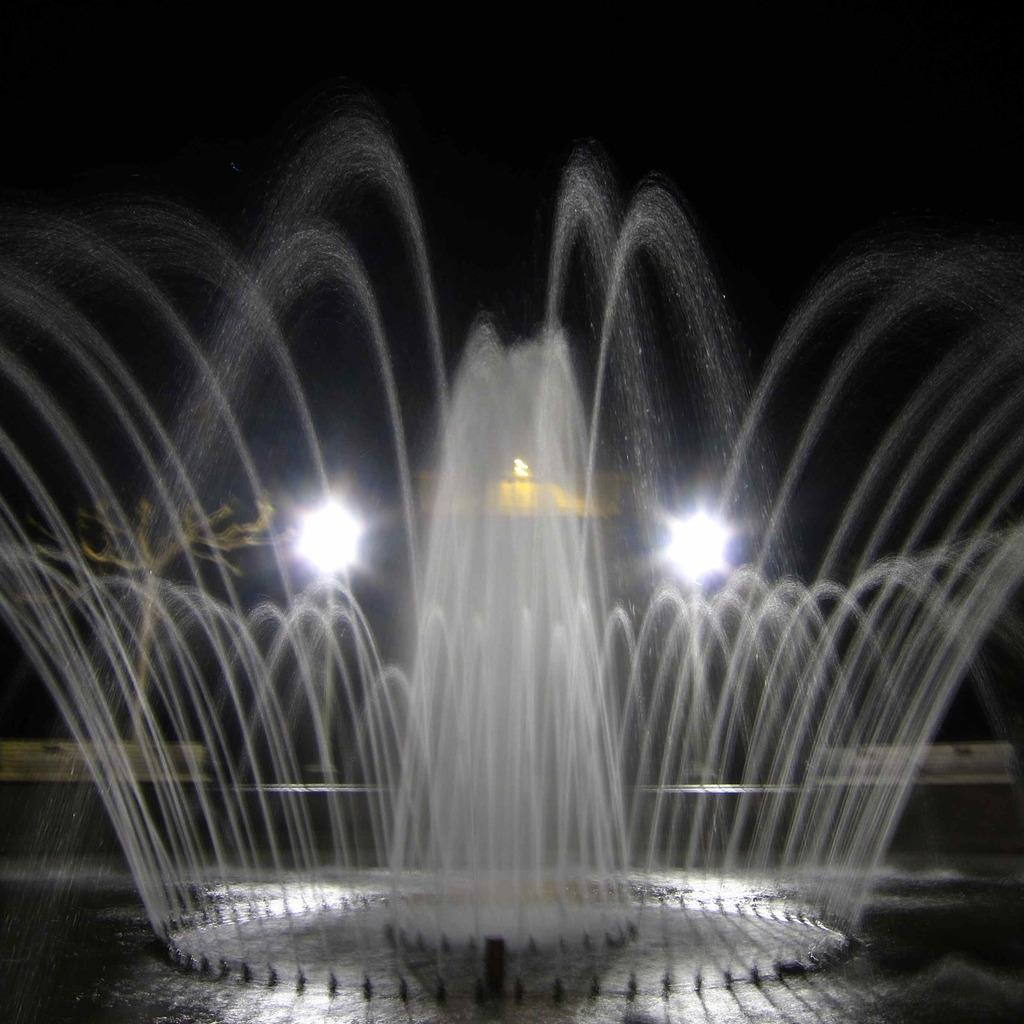What is the main feature in the image? There is a fountain in the image. Can you describe the lighting in the image? There are two lights visible in the background of the image. What shape is the wheel in the image? There is no wheel present in the image. What is the reason for the fountain in the image? The reason for the fountain in the image cannot be determined from the image alone. 